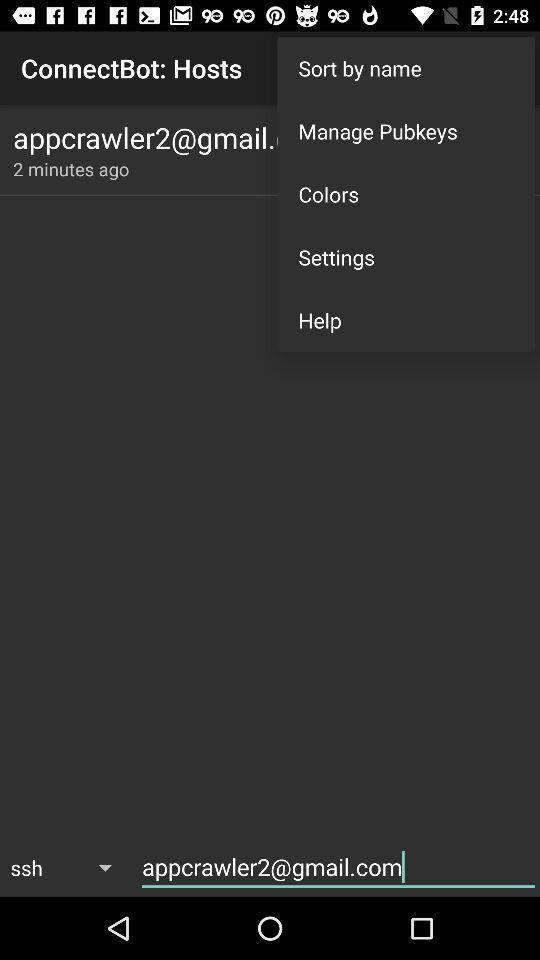How many text inputs are there that are not in the same row as the text 'ConnectBot: Hosts'?
Answer the question using a single word or phrase. 1 